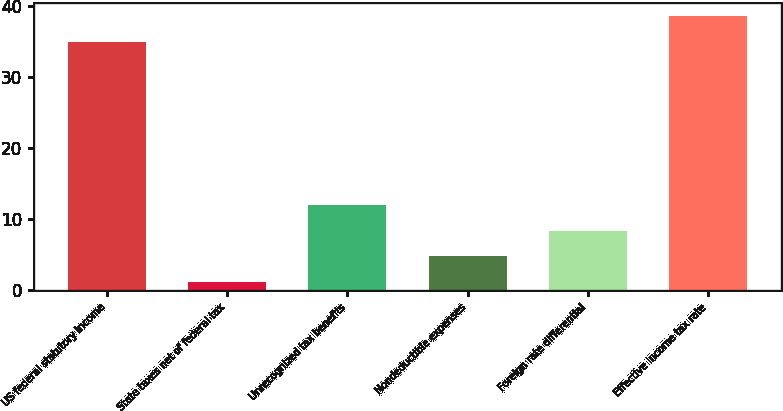Convert chart to OTSL. <chart><loc_0><loc_0><loc_500><loc_500><bar_chart><fcel>US federal statutory income<fcel>State taxes net of federal tax<fcel>Unrecognized tax benefits<fcel>Nondeductible expenses<fcel>Foreign rate differential<fcel>Effective income tax rate<nl><fcel>35<fcel>1.2<fcel>11.97<fcel>4.79<fcel>8.38<fcel>38.59<nl></chart> 